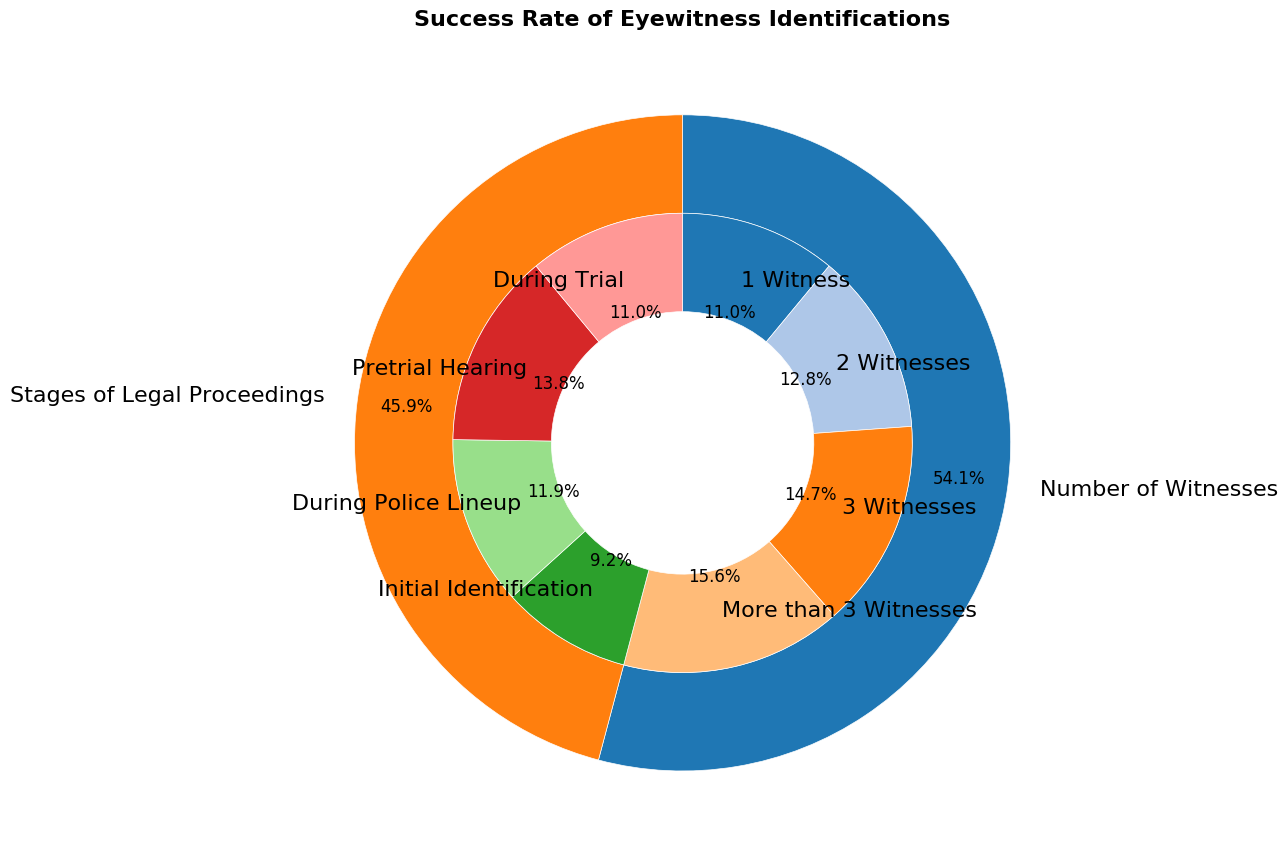What's the subcategory with the highest success rate? Look at the innermost ring segments of the pie chart and identify the one with the largest numerical value. "More than 3 Witnesses" has the highest value of 85.
Answer: More than 3 Witnesses Which stage of the legal proceedings has the lowest success rate? Check the subcategories under "Stages of Legal Proceedings" and find the one with the smallest value. "Initial Identification" has the smallest value of 50.
Answer: Initial Identification How does the success rate of 2 Witnesses compare to During Trial? Compare the values of "2 Witnesses" and "During Trial" from the corresponding sections. "2 Witnesses" has a success rate of 70, while "During Trial" has 60. Therefore, "2 Witnesses" has a higher success rate.
Answer: 2 Witnesses > During Trial What is the combined success rate of Initial Identification and During Police Lineup? Add the percentages of "Initial Identification" (50) and "During Police Lineup" (65). The combined success rate is 50 + 65 = 115.
Answer: 115 Which category contributes the most to the overall success rates shown in the figure? Examine the outer ring of the pie chart to determine which category occupies the most space. "Number of Witnesses" has more subdivisions and larger values in general compared to "Stages of Legal Proceedings".
Answer: Number of Witnesses What is the average success rate of all subcategories? Sum all the values of the subcategories and divide by the total number of subcategories. The total sum is (60 + 70 + 80 + 85 + 50 + 65 + 75 + 60) = 545. There are 8 subcategories, so the average is 545 / 8 = 68.125.
Answer: 68.125 If you were to group the success rates for "During Police Lineup" and "Pretrial Hearing," would the total be more than the combined success rate of "3 Witnesses" and "More than 3 Witnesses"? Calculate the combined success rates for both groups: "During Police Lineup" (65) + "Pretrial Hearing" (75) = 140 and "3 Witnesses" (80) + "More than 3 Witnesses" (85) = 165. Compare the sums: 140 < 165.
Answer: No Which success rate is closer to the overall average, 1 Witness or During Trial? First, recall the overall average calculated as 68.125. Then, compare the distances from this average for "1 Witness" (60) and "During Trial" (60). Both are equidistant to the average, differing by 8.125.
Answer: Both 1 Witness and During Trial Are there more subcategories with a success rate above 70 or below 70? Count the subcategories with values above 70 (3 Witnesses (80), More than 3 Witnesses (85), Pretrial Hearing (75)) and those below 70  (1 Witness (60), 2 Witnesses (70), Initial Identification (50), During Police Lineup (65), During Trial (60)). There are 3 subcategories above 70 and 5 below.
Answer: Below 70 